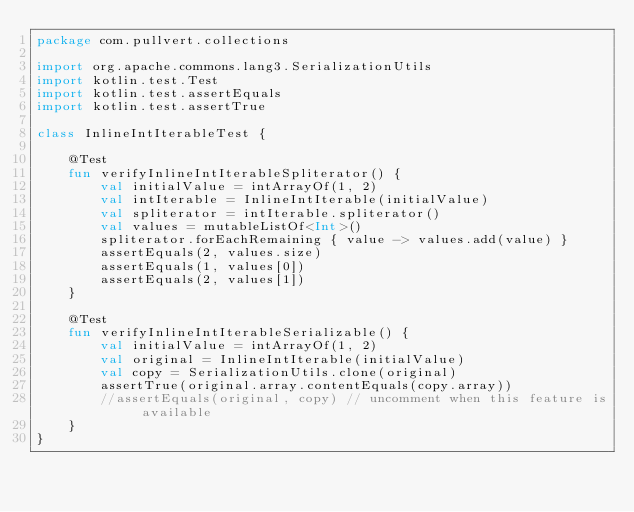Convert code to text. <code><loc_0><loc_0><loc_500><loc_500><_Kotlin_>package com.pullvert.collections

import org.apache.commons.lang3.SerializationUtils
import kotlin.test.Test
import kotlin.test.assertEquals
import kotlin.test.assertTrue

class InlineIntIterableTest {

    @Test
    fun verifyInlineIntIterableSpliterator() {
        val initialValue = intArrayOf(1, 2)
        val intIterable = InlineIntIterable(initialValue)
        val spliterator = intIterable.spliterator()
        val values = mutableListOf<Int>()
        spliterator.forEachRemaining { value -> values.add(value) }
        assertEquals(2, values.size)
        assertEquals(1, values[0])
        assertEquals(2, values[1])
    }

    @Test
    fun verifyInlineIntIterableSerializable() {
        val initialValue = intArrayOf(1, 2)
        val original = InlineIntIterable(initialValue)
        val copy = SerializationUtils.clone(original)
        assertTrue(original.array.contentEquals(copy.array))
        //assertEquals(original, copy) // uncomment when this feature is available
    }
}
</code> 